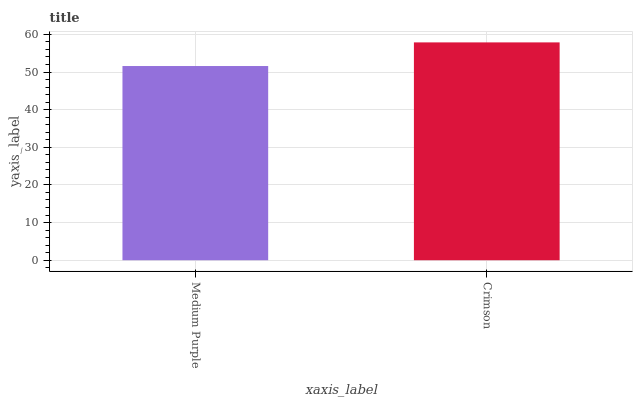Is Medium Purple the minimum?
Answer yes or no. Yes. Is Crimson the maximum?
Answer yes or no. Yes. Is Crimson the minimum?
Answer yes or no. No. Is Crimson greater than Medium Purple?
Answer yes or no. Yes. Is Medium Purple less than Crimson?
Answer yes or no. Yes. Is Medium Purple greater than Crimson?
Answer yes or no. No. Is Crimson less than Medium Purple?
Answer yes or no. No. Is Crimson the high median?
Answer yes or no. Yes. Is Medium Purple the low median?
Answer yes or no. Yes. Is Medium Purple the high median?
Answer yes or no. No. Is Crimson the low median?
Answer yes or no. No. 